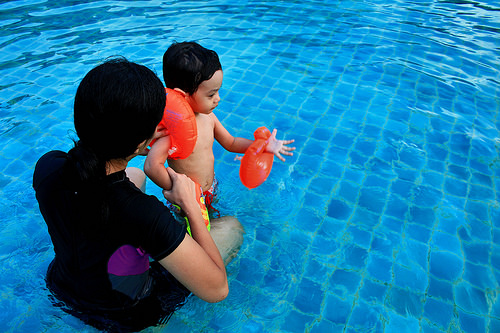<image>
Can you confirm if the woman is under the child? No. The woman is not positioned under the child. The vertical relationship between these objects is different. Where is the child in relation to the water? Is it in the water? Yes. The child is contained within or inside the water, showing a containment relationship. 